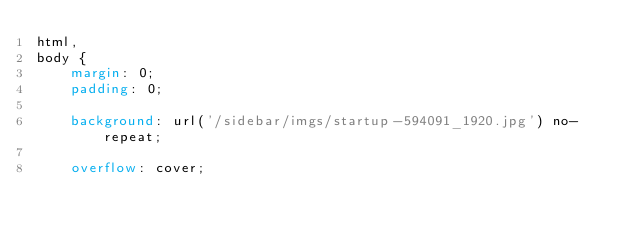<code> <loc_0><loc_0><loc_500><loc_500><_CSS_>html,
body {
    margin: 0;
    padding: 0;

    background: url('/sidebar/imgs/startup-594091_1920.jpg') no-repeat;

    overflow: cover;</code> 